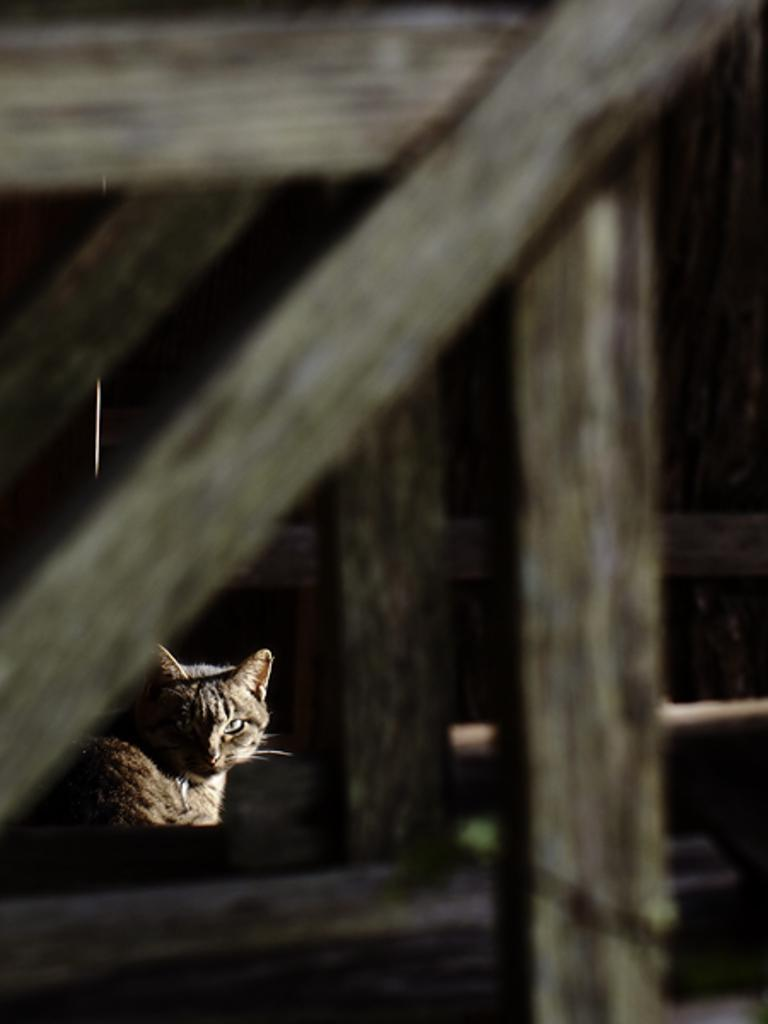What type of animal is in the image? There is a cat in the image. What material are the frames made of in the image? The frames in the image are made of wood. What type of yoke is being used by the cat in the image? There is no yoke present in the image, and the cat is not using any yoke. 